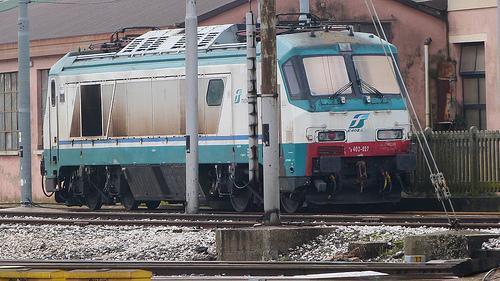How many trains are there?
Give a very brief answer. 1. 